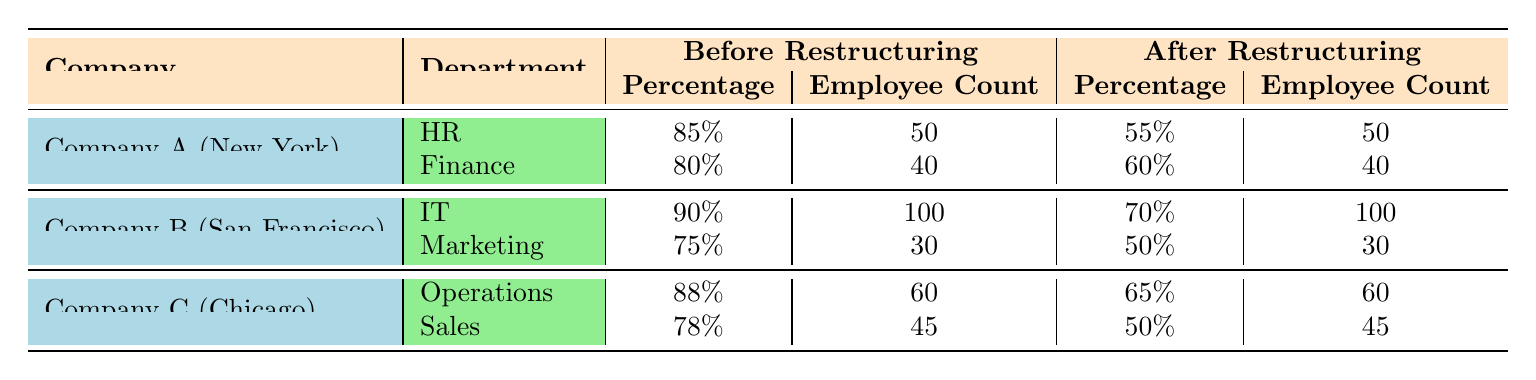What was the job security perception percentage for the HR department in Company A before restructuring? The HR department in Company A had a job security perception percentage of 85% before restructuring, as indicated in the table under the "Before Restructuring" column.
Answer: 85% What is the employee count for the Marketing department in Company B after restructuring? The employee count for the Marketing department in Company B after restructuring is 30, as shown in the table under the "After Restructuring" column.
Answer: 30 Which department in Company C had the highest job security perception percentage after restructuring? The Operations department in Company C had the highest job security perception percentage after restructuring at 65%, compared to the Sales department which had 50%.
Answer: Operations Did the job security perception for the IT department in Company B increase or decrease after restructuring? The job security perception for the IT department in Company B decreased from 90% to 70% after restructuring, as indicated in the respective columns for before and after restructuring.
Answer: Decrease What is the average job security perception percentage for all departments in Company A before restructuring? The average job security perception for Company A can be calculated by taking the percentages (85% + 80%) and dividing by the number of departments (2): (85 + 80) / 2 = 82.5%.
Answer: 82.5% Which company had the highest overall job security perception percentage before restructuring? To find this, we compare the highest percentages from each company: Company A (HR 85%, Finance 80%), Company B (IT 90%, Marketing 75%), and Company C (Operations 88%, Sales 78%). Company B has the highest value at 90% in the IT department.
Answer: Company B Is it true that all departments in Company C experienced a decrease in job security perception after restructuring? Yes, both the Operations and Sales departments in Company C saw a decrease in job security perception after restructuring, with Operations falling from 88% to 65% and Sales from 78% to 50%.
Answer: True What was the total employee count for Company A across both departments before restructuring? The total employee count for Company A before restructuring is 50 (HR) + 40 (Finance) = 90 employees in total across both departments.
Answer: 90 What was the percentage decrease in job security perception for the Finance department in Company A after restructuring? The Finance department's job security perception percentage decreased from 80% to 60%, which is a decrease of 20%. This can be calculated as 80% - 60% = 20%.
Answer: 20% 